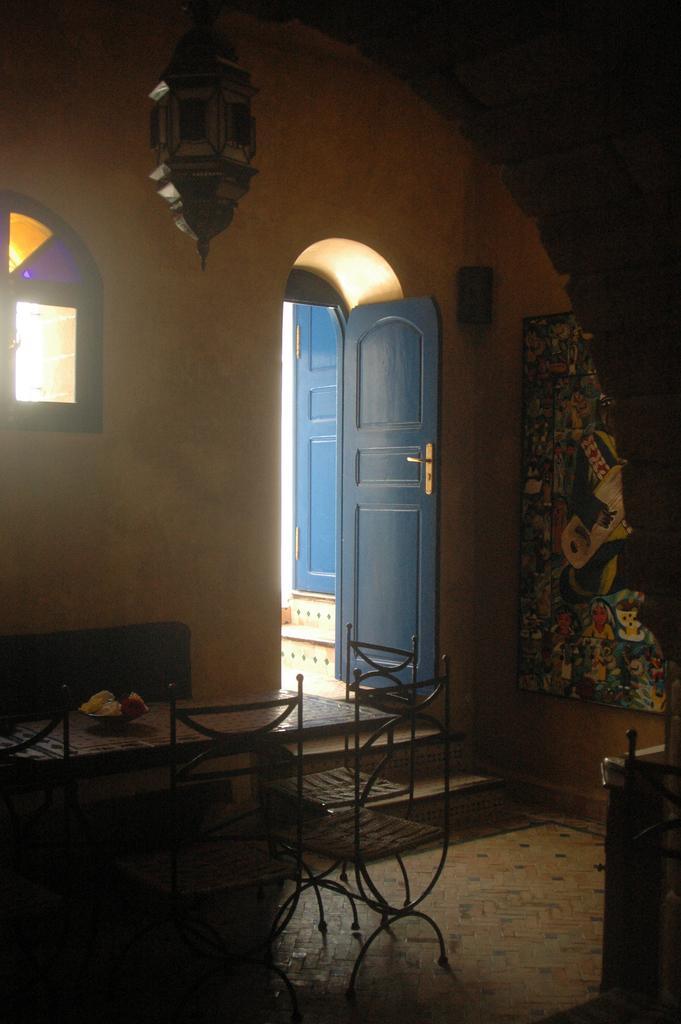In one or two sentences, can you explain what this image depicts? This image is taken indoors. At the bottom of the image there is a floor. In the background there is a wall and there are two doors. There is a window. There is a painting on the wall. In the middle of the image there is a table with a bowl on it and there are a few empty chairs around the table. At the top of the image there is a lamp. 